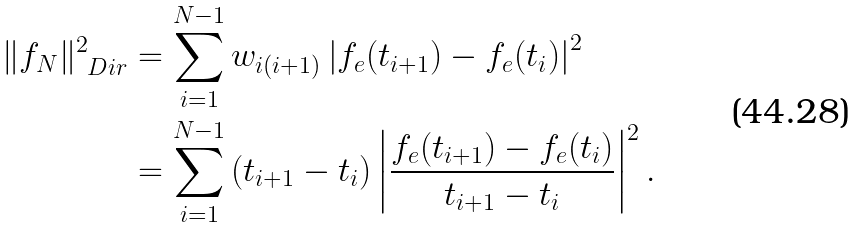Convert formula to latex. <formula><loc_0><loc_0><loc_500><loc_500>\| f _ { N } \| ^ { 2 } _ { \ D i r } & = \sum _ { i = 1 } ^ { N - 1 } w _ { i ( i + 1 ) } \left | f _ { e } ( t _ { i + 1 } ) - f _ { e } ( t _ { i } ) \right | ^ { 2 } \\ & = \sum _ { i = 1 } ^ { N - 1 } \left ( t _ { i + 1 } - t _ { i } \right ) \left | \frac { f _ { e } ( t _ { i + 1 } ) - f _ { e } ( t _ { i } ) } { t _ { i + 1 } - t _ { i } } \right | ^ { 2 } .</formula> 